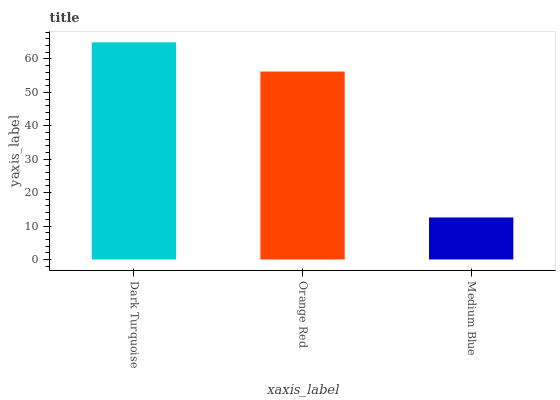Is Medium Blue the minimum?
Answer yes or no. Yes. Is Dark Turquoise the maximum?
Answer yes or no. Yes. Is Orange Red the minimum?
Answer yes or no. No. Is Orange Red the maximum?
Answer yes or no. No. Is Dark Turquoise greater than Orange Red?
Answer yes or no. Yes. Is Orange Red less than Dark Turquoise?
Answer yes or no. Yes. Is Orange Red greater than Dark Turquoise?
Answer yes or no. No. Is Dark Turquoise less than Orange Red?
Answer yes or no. No. Is Orange Red the high median?
Answer yes or no. Yes. Is Orange Red the low median?
Answer yes or no. Yes. Is Dark Turquoise the high median?
Answer yes or no. No. Is Dark Turquoise the low median?
Answer yes or no. No. 